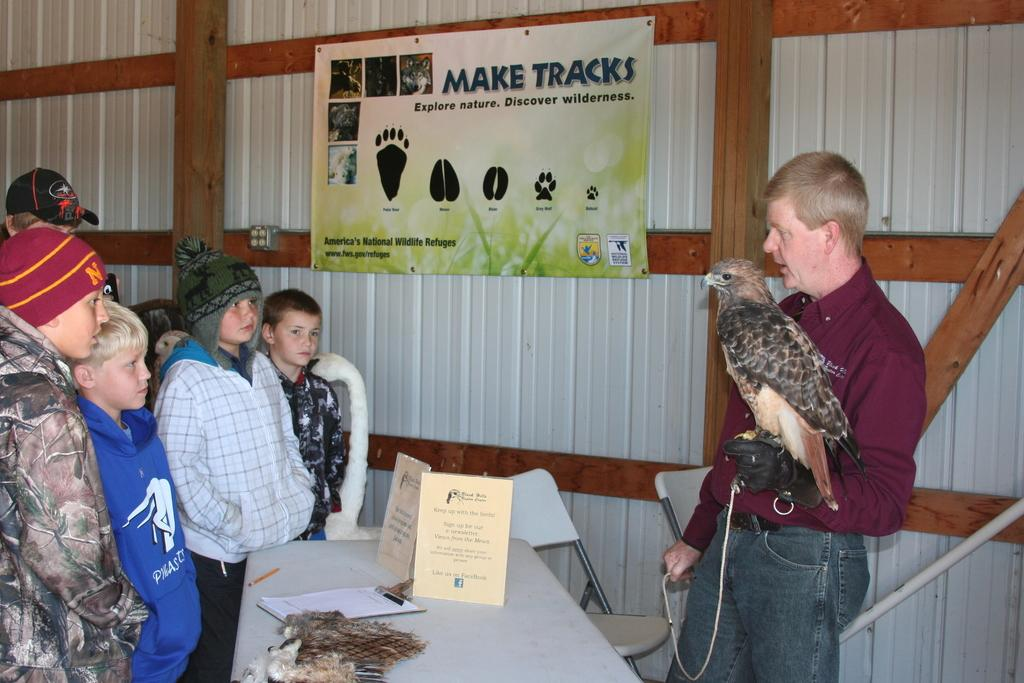How many people are in the image? There are people in the image, but the exact number is not specified. What type of furniture is in the image? There is a table and chairs in the image. What is on the table in the image? There is a writing pad in the image. What is on the writing pad? There are papers in the image. What is the object in the image? The object in the image is not described in detail. What can be seen in the background of the image? There is a wall and a banner in the background of the image. What type of liquid is being poured from the banner in the image? There is no liquid being poured in the image; the banner is simply hanging in the background. 